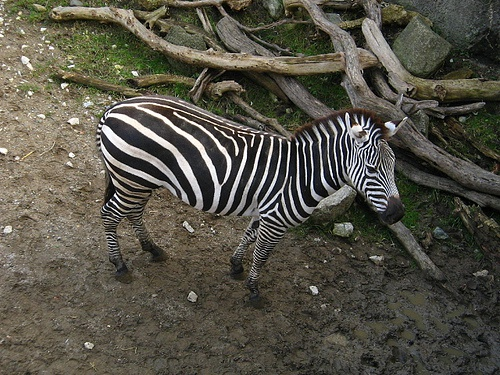Describe the objects in this image and their specific colors. I can see a zebra in gray, black, lightgray, and darkgray tones in this image. 